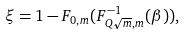<formula> <loc_0><loc_0><loc_500><loc_500>\xi = 1 - F _ { 0 , m } ( F ^ { - 1 } _ { Q \sqrt { m } , m } ( \beta ) ) ,</formula> 